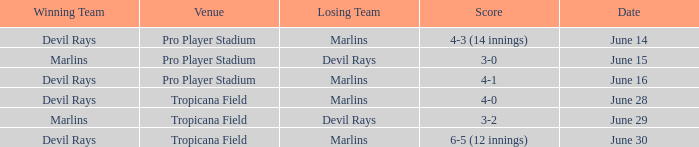What was the score on june 29? 3-2. 